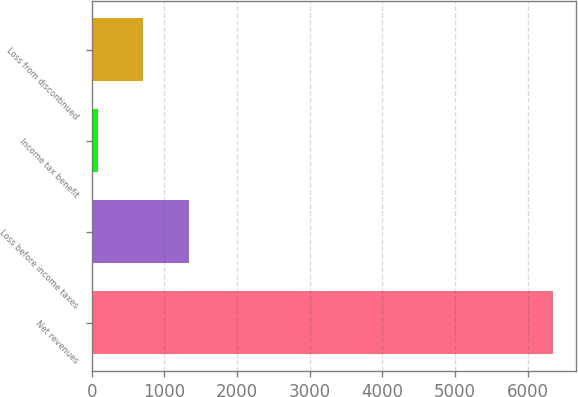<chart> <loc_0><loc_0><loc_500><loc_500><bar_chart><fcel>Net revenues<fcel>Loss before income taxes<fcel>Income tax benefit<fcel>Loss from discontinued<nl><fcel>6351<fcel>1337.4<fcel>84<fcel>710.7<nl></chart> 